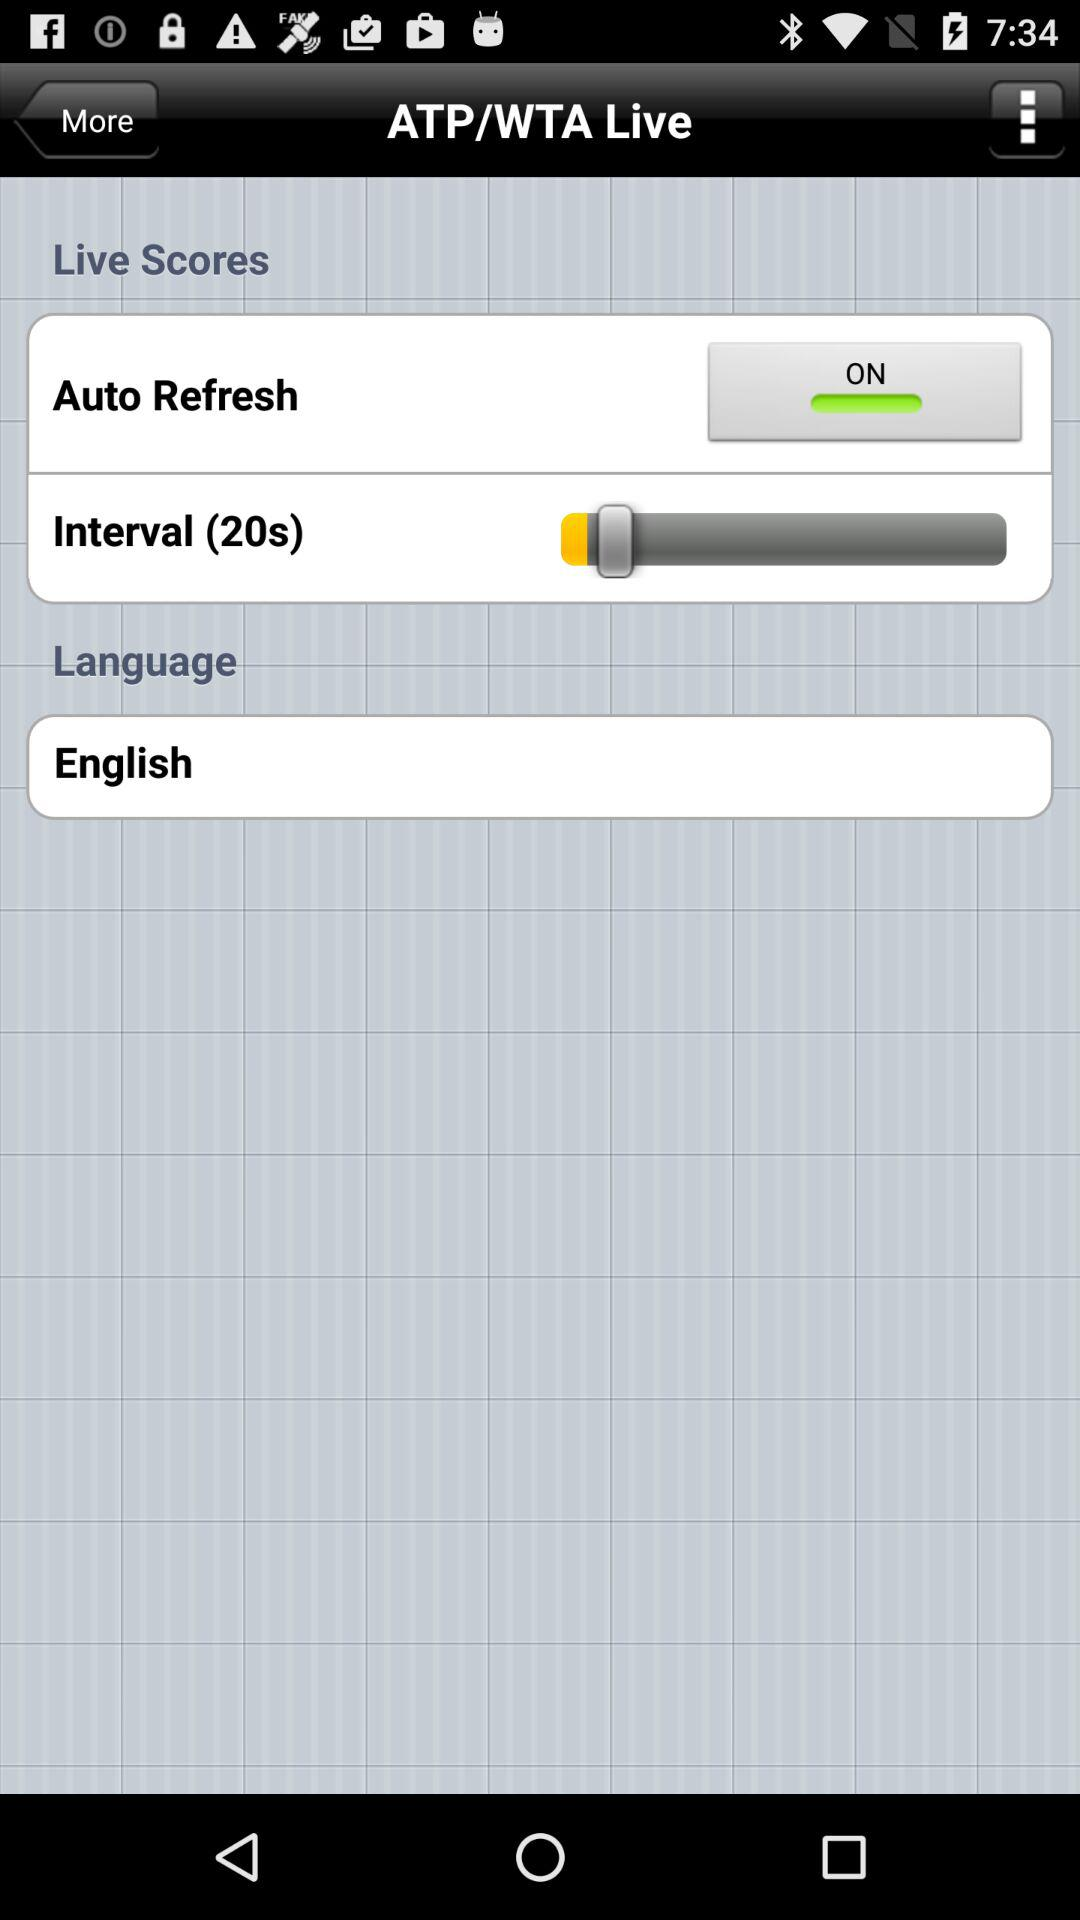What is the status of "Auto Refresh"? The status is "on". 